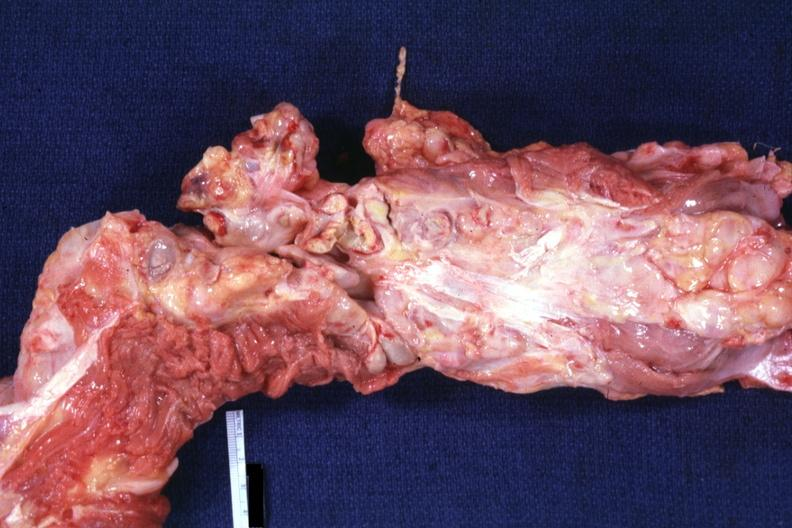s lymph node present?
Answer the question using a single word or phrase. Yes 